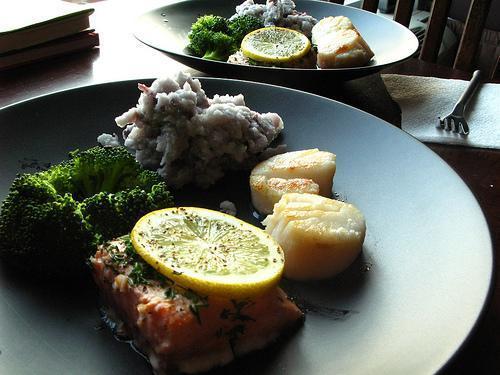How many scallops are there?
Give a very brief answer. 2. 